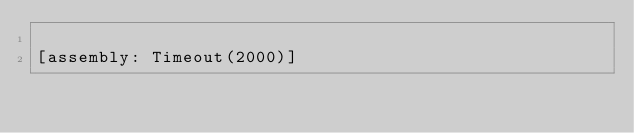<code> <loc_0><loc_0><loc_500><loc_500><_C#_>
[assembly: Timeout(2000)]</code> 